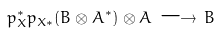Convert formula to latex. <formula><loc_0><loc_0><loc_500><loc_500>p ^ { * } _ { X } p _ { X * } ( B \otimes A ^ { * } ) \otimes A \, \longrightarrow \, B</formula> 